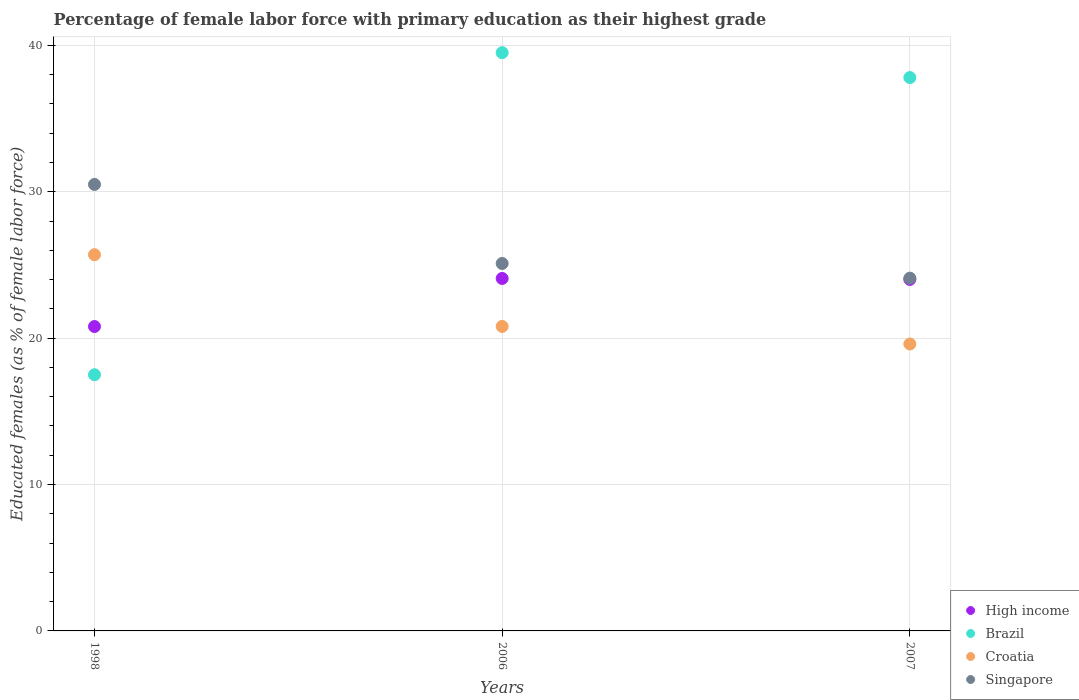How many different coloured dotlines are there?
Offer a very short reply. 4. Is the number of dotlines equal to the number of legend labels?
Your answer should be very brief. Yes. What is the percentage of female labor force with primary education in Croatia in 2007?
Offer a terse response. 19.6. Across all years, what is the maximum percentage of female labor force with primary education in High income?
Your response must be concise. 24.08. Across all years, what is the minimum percentage of female labor force with primary education in Croatia?
Your answer should be very brief. 19.6. In which year was the percentage of female labor force with primary education in Croatia minimum?
Provide a short and direct response. 2007. What is the total percentage of female labor force with primary education in Croatia in the graph?
Offer a terse response. 66.1. What is the difference between the percentage of female labor force with primary education in Brazil in 1998 and that in 2007?
Your answer should be compact. -20.3. What is the difference between the percentage of female labor force with primary education in Singapore in 2006 and the percentage of female labor force with primary education in High income in 2007?
Give a very brief answer. 1.09. What is the average percentage of female labor force with primary education in Croatia per year?
Give a very brief answer. 22.03. In the year 2007, what is the difference between the percentage of female labor force with primary education in High income and percentage of female labor force with primary education in Brazil?
Provide a short and direct response. -13.79. In how many years, is the percentage of female labor force with primary education in Croatia greater than 18 %?
Provide a succinct answer. 3. What is the ratio of the percentage of female labor force with primary education in High income in 1998 to that in 2007?
Provide a short and direct response. 0.87. Is the percentage of female labor force with primary education in Croatia in 1998 less than that in 2007?
Give a very brief answer. No. What is the difference between the highest and the second highest percentage of female labor force with primary education in Croatia?
Ensure brevity in your answer.  4.9. What is the difference between the highest and the lowest percentage of female labor force with primary education in High income?
Ensure brevity in your answer.  3.28. Is the sum of the percentage of female labor force with primary education in Singapore in 1998 and 2006 greater than the maximum percentage of female labor force with primary education in High income across all years?
Your response must be concise. Yes. Is it the case that in every year, the sum of the percentage of female labor force with primary education in High income and percentage of female labor force with primary education in Singapore  is greater than the sum of percentage of female labor force with primary education in Brazil and percentage of female labor force with primary education in Croatia?
Provide a succinct answer. No. Does the percentage of female labor force with primary education in High income monotonically increase over the years?
Give a very brief answer. No. How many dotlines are there?
Keep it short and to the point. 4. How many years are there in the graph?
Make the answer very short. 3. Are the values on the major ticks of Y-axis written in scientific E-notation?
Your answer should be compact. No. Does the graph contain any zero values?
Keep it short and to the point. No. Does the graph contain grids?
Keep it short and to the point. Yes. Where does the legend appear in the graph?
Offer a terse response. Bottom right. How are the legend labels stacked?
Keep it short and to the point. Vertical. What is the title of the graph?
Keep it short and to the point. Percentage of female labor force with primary education as their highest grade. What is the label or title of the Y-axis?
Offer a very short reply. Educated females (as % of female labor force). What is the Educated females (as % of female labor force) in High income in 1998?
Your answer should be very brief. 20.79. What is the Educated females (as % of female labor force) of Brazil in 1998?
Keep it short and to the point. 17.5. What is the Educated females (as % of female labor force) of Croatia in 1998?
Your answer should be compact. 25.7. What is the Educated females (as % of female labor force) in Singapore in 1998?
Make the answer very short. 30.5. What is the Educated females (as % of female labor force) in High income in 2006?
Your response must be concise. 24.08. What is the Educated females (as % of female labor force) of Brazil in 2006?
Ensure brevity in your answer.  39.5. What is the Educated females (as % of female labor force) of Croatia in 2006?
Make the answer very short. 20.8. What is the Educated females (as % of female labor force) of Singapore in 2006?
Ensure brevity in your answer.  25.1. What is the Educated females (as % of female labor force) in High income in 2007?
Provide a short and direct response. 24.01. What is the Educated females (as % of female labor force) of Brazil in 2007?
Your response must be concise. 37.8. What is the Educated females (as % of female labor force) of Croatia in 2007?
Your answer should be very brief. 19.6. What is the Educated females (as % of female labor force) in Singapore in 2007?
Your answer should be compact. 24.1. Across all years, what is the maximum Educated females (as % of female labor force) in High income?
Provide a succinct answer. 24.08. Across all years, what is the maximum Educated females (as % of female labor force) of Brazil?
Give a very brief answer. 39.5. Across all years, what is the maximum Educated females (as % of female labor force) of Croatia?
Your answer should be very brief. 25.7. Across all years, what is the maximum Educated females (as % of female labor force) in Singapore?
Ensure brevity in your answer.  30.5. Across all years, what is the minimum Educated females (as % of female labor force) in High income?
Provide a short and direct response. 20.79. Across all years, what is the minimum Educated females (as % of female labor force) of Brazil?
Your response must be concise. 17.5. Across all years, what is the minimum Educated females (as % of female labor force) of Croatia?
Your answer should be very brief. 19.6. Across all years, what is the minimum Educated females (as % of female labor force) of Singapore?
Keep it short and to the point. 24.1. What is the total Educated females (as % of female labor force) of High income in the graph?
Give a very brief answer. 68.88. What is the total Educated females (as % of female labor force) of Brazil in the graph?
Your answer should be very brief. 94.8. What is the total Educated females (as % of female labor force) in Croatia in the graph?
Provide a succinct answer. 66.1. What is the total Educated females (as % of female labor force) in Singapore in the graph?
Keep it short and to the point. 79.7. What is the difference between the Educated females (as % of female labor force) in High income in 1998 and that in 2006?
Make the answer very short. -3.28. What is the difference between the Educated females (as % of female labor force) in Brazil in 1998 and that in 2006?
Offer a very short reply. -22. What is the difference between the Educated females (as % of female labor force) in Singapore in 1998 and that in 2006?
Give a very brief answer. 5.4. What is the difference between the Educated females (as % of female labor force) in High income in 1998 and that in 2007?
Give a very brief answer. -3.22. What is the difference between the Educated females (as % of female labor force) of Brazil in 1998 and that in 2007?
Your response must be concise. -20.3. What is the difference between the Educated females (as % of female labor force) in High income in 2006 and that in 2007?
Your answer should be compact. 0.07. What is the difference between the Educated females (as % of female labor force) in Croatia in 2006 and that in 2007?
Your response must be concise. 1.2. What is the difference between the Educated females (as % of female labor force) in Singapore in 2006 and that in 2007?
Your response must be concise. 1. What is the difference between the Educated females (as % of female labor force) of High income in 1998 and the Educated females (as % of female labor force) of Brazil in 2006?
Give a very brief answer. -18.71. What is the difference between the Educated females (as % of female labor force) in High income in 1998 and the Educated females (as % of female labor force) in Croatia in 2006?
Your answer should be compact. -0.01. What is the difference between the Educated females (as % of female labor force) of High income in 1998 and the Educated females (as % of female labor force) of Singapore in 2006?
Your answer should be compact. -4.31. What is the difference between the Educated females (as % of female labor force) in Brazil in 1998 and the Educated females (as % of female labor force) in Singapore in 2006?
Ensure brevity in your answer.  -7.6. What is the difference between the Educated females (as % of female labor force) of Croatia in 1998 and the Educated females (as % of female labor force) of Singapore in 2006?
Give a very brief answer. 0.6. What is the difference between the Educated females (as % of female labor force) in High income in 1998 and the Educated females (as % of female labor force) in Brazil in 2007?
Give a very brief answer. -17.01. What is the difference between the Educated females (as % of female labor force) in High income in 1998 and the Educated females (as % of female labor force) in Croatia in 2007?
Your answer should be compact. 1.19. What is the difference between the Educated females (as % of female labor force) of High income in 1998 and the Educated females (as % of female labor force) of Singapore in 2007?
Offer a very short reply. -3.31. What is the difference between the Educated females (as % of female labor force) in Brazil in 1998 and the Educated females (as % of female labor force) in Singapore in 2007?
Give a very brief answer. -6.6. What is the difference between the Educated females (as % of female labor force) of Croatia in 1998 and the Educated females (as % of female labor force) of Singapore in 2007?
Provide a short and direct response. 1.6. What is the difference between the Educated females (as % of female labor force) in High income in 2006 and the Educated females (as % of female labor force) in Brazil in 2007?
Your answer should be very brief. -13.72. What is the difference between the Educated females (as % of female labor force) in High income in 2006 and the Educated females (as % of female labor force) in Croatia in 2007?
Ensure brevity in your answer.  4.48. What is the difference between the Educated females (as % of female labor force) in High income in 2006 and the Educated females (as % of female labor force) in Singapore in 2007?
Make the answer very short. -0.02. What is the difference between the Educated females (as % of female labor force) of Brazil in 2006 and the Educated females (as % of female labor force) of Croatia in 2007?
Provide a short and direct response. 19.9. What is the difference between the Educated females (as % of female labor force) of Croatia in 2006 and the Educated females (as % of female labor force) of Singapore in 2007?
Offer a terse response. -3.3. What is the average Educated females (as % of female labor force) in High income per year?
Provide a short and direct response. 22.96. What is the average Educated females (as % of female labor force) of Brazil per year?
Offer a terse response. 31.6. What is the average Educated females (as % of female labor force) of Croatia per year?
Provide a short and direct response. 22.03. What is the average Educated females (as % of female labor force) of Singapore per year?
Make the answer very short. 26.57. In the year 1998, what is the difference between the Educated females (as % of female labor force) of High income and Educated females (as % of female labor force) of Brazil?
Make the answer very short. 3.29. In the year 1998, what is the difference between the Educated females (as % of female labor force) in High income and Educated females (as % of female labor force) in Croatia?
Your answer should be compact. -4.91. In the year 1998, what is the difference between the Educated females (as % of female labor force) of High income and Educated females (as % of female labor force) of Singapore?
Give a very brief answer. -9.71. In the year 1998, what is the difference between the Educated females (as % of female labor force) in Brazil and Educated females (as % of female labor force) in Singapore?
Make the answer very short. -13. In the year 2006, what is the difference between the Educated females (as % of female labor force) of High income and Educated females (as % of female labor force) of Brazil?
Your answer should be very brief. -15.42. In the year 2006, what is the difference between the Educated females (as % of female labor force) of High income and Educated females (as % of female labor force) of Croatia?
Your answer should be compact. 3.28. In the year 2006, what is the difference between the Educated females (as % of female labor force) in High income and Educated females (as % of female labor force) in Singapore?
Provide a short and direct response. -1.02. In the year 2006, what is the difference between the Educated females (as % of female labor force) in Brazil and Educated females (as % of female labor force) in Singapore?
Ensure brevity in your answer.  14.4. In the year 2006, what is the difference between the Educated females (as % of female labor force) of Croatia and Educated females (as % of female labor force) of Singapore?
Your response must be concise. -4.3. In the year 2007, what is the difference between the Educated females (as % of female labor force) of High income and Educated females (as % of female labor force) of Brazil?
Provide a short and direct response. -13.79. In the year 2007, what is the difference between the Educated females (as % of female labor force) of High income and Educated females (as % of female labor force) of Croatia?
Your response must be concise. 4.41. In the year 2007, what is the difference between the Educated females (as % of female labor force) in High income and Educated females (as % of female labor force) in Singapore?
Keep it short and to the point. -0.09. What is the ratio of the Educated females (as % of female labor force) in High income in 1998 to that in 2006?
Your answer should be very brief. 0.86. What is the ratio of the Educated females (as % of female labor force) in Brazil in 1998 to that in 2006?
Give a very brief answer. 0.44. What is the ratio of the Educated females (as % of female labor force) in Croatia in 1998 to that in 2006?
Give a very brief answer. 1.24. What is the ratio of the Educated females (as % of female labor force) in Singapore in 1998 to that in 2006?
Your answer should be very brief. 1.22. What is the ratio of the Educated females (as % of female labor force) of High income in 1998 to that in 2007?
Ensure brevity in your answer.  0.87. What is the ratio of the Educated females (as % of female labor force) of Brazil in 1998 to that in 2007?
Offer a very short reply. 0.46. What is the ratio of the Educated females (as % of female labor force) of Croatia in 1998 to that in 2007?
Offer a very short reply. 1.31. What is the ratio of the Educated females (as % of female labor force) in Singapore in 1998 to that in 2007?
Your answer should be very brief. 1.27. What is the ratio of the Educated females (as % of female labor force) in Brazil in 2006 to that in 2007?
Offer a terse response. 1.04. What is the ratio of the Educated females (as % of female labor force) in Croatia in 2006 to that in 2007?
Keep it short and to the point. 1.06. What is the ratio of the Educated females (as % of female labor force) in Singapore in 2006 to that in 2007?
Your response must be concise. 1.04. What is the difference between the highest and the second highest Educated females (as % of female labor force) in High income?
Offer a terse response. 0.07. What is the difference between the highest and the second highest Educated females (as % of female labor force) of Croatia?
Your answer should be very brief. 4.9. What is the difference between the highest and the second highest Educated females (as % of female labor force) in Singapore?
Provide a short and direct response. 5.4. What is the difference between the highest and the lowest Educated females (as % of female labor force) of High income?
Your answer should be compact. 3.28. What is the difference between the highest and the lowest Educated females (as % of female labor force) in Croatia?
Make the answer very short. 6.1. 